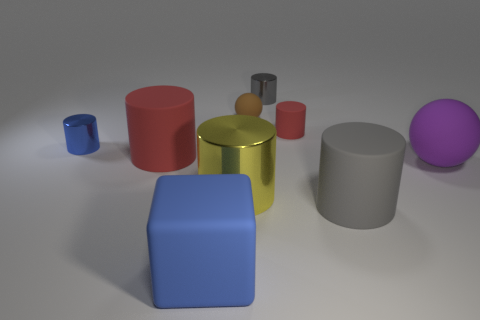Is the small gray cylinder that is right of the brown rubber ball made of the same material as the large purple thing?
Your response must be concise. No. Is there anything else that is the same size as the yellow metallic object?
Your answer should be very brief. Yes. Are there fewer small things to the right of the tiny sphere than brown matte things to the right of the large metal object?
Make the answer very short. No. Are there any other things that are the same shape as the large purple object?
Offer a very short reply. Yes. There is a small object that is the same color as the rubber cube; what material is it?
Offer a very short reply. Metal. There is a red rubber thing that is behind the red matte cylinder that is on the left side of the small gray metal cylinder; how many tiny gray things are right of it?
Your answer should be very brief. 0. There is a big red matte cylinder; what number of small red rubber cylinders are behind it?
Your answer should be very brief. 1. How many large balls are made of the same material as the large yellow cylinder?
Offer a very short reply. 0. What is the color of the tiny sphere that is made of the same material as the blue cube?
Give a very brief answer. Brown. What is the blue object that is in front of the blue shiny cylinder that is behind the large red matte cylinder to the left of the big yellow shiny thing made of?
Give a very brief answer. Rubber. 